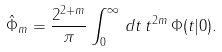<formula> <loc_0><loc_0><loc_500><loc_500>\hat { \Phi } _ { m } = { \frac { 2 ^ { 2 + m } } { \pi } } \int _ { 0 } ^ { \infty } \, d t \, t ^ { 2 m } \, \Phi ( t | 0 ) .</formula> 